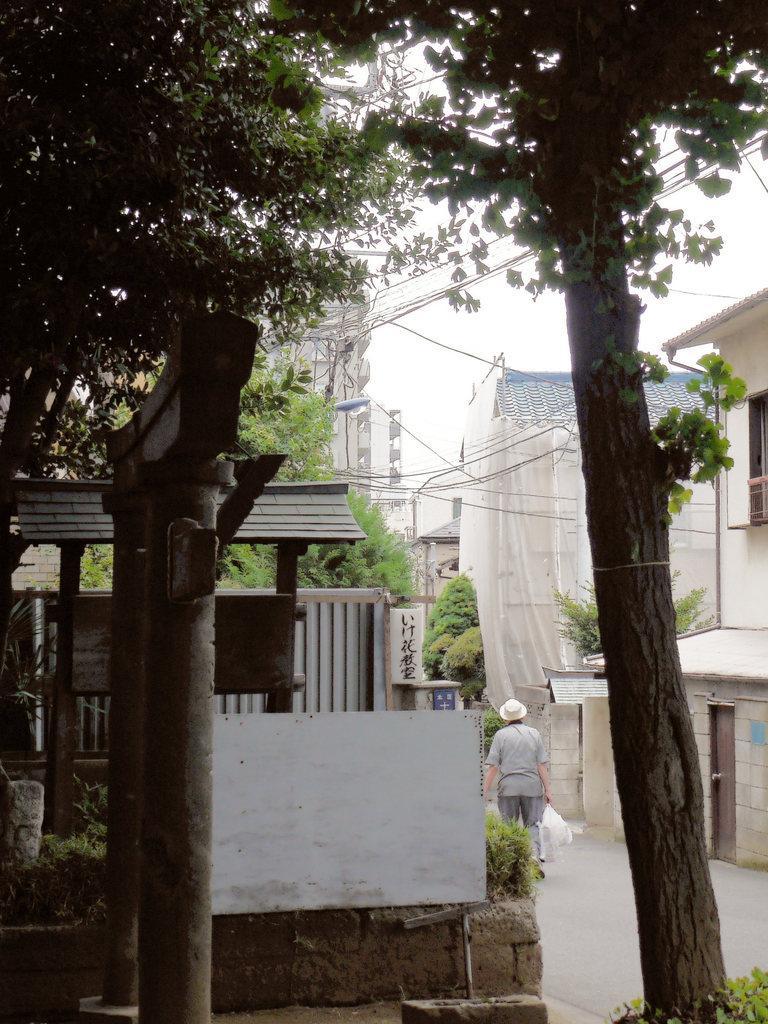Could you give a brief overview of what you see in this image? In this picture we can see trees, wires, archways, buildings, plants, person holding plastic covers on the road and in the background we can see the sky. 